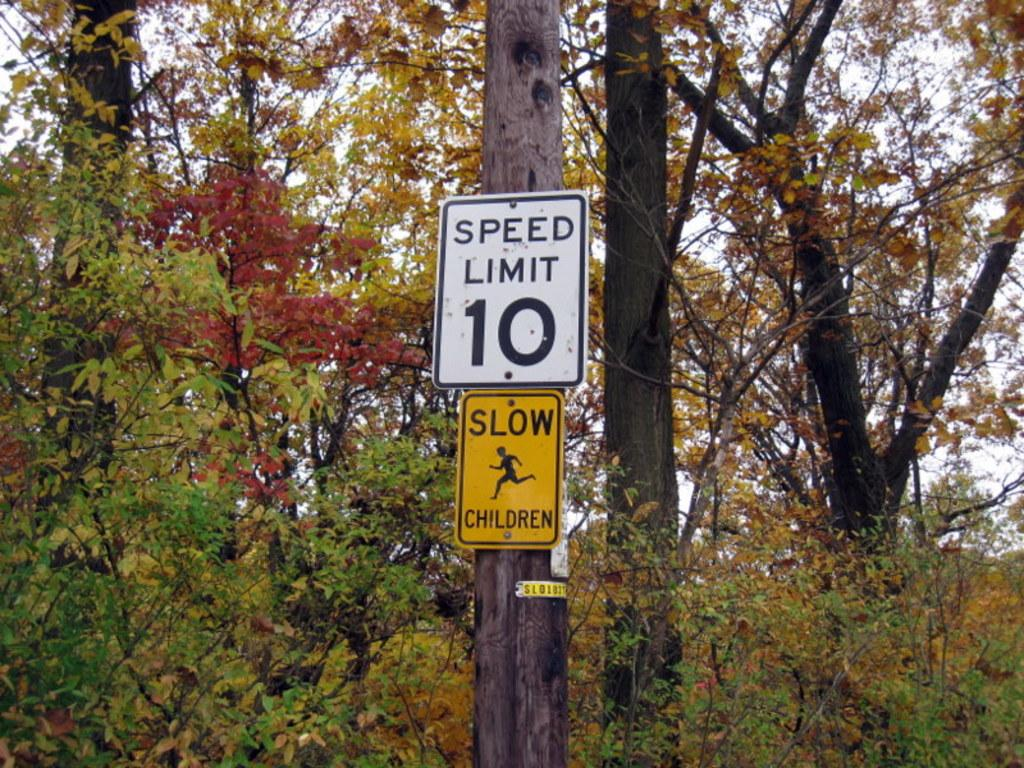What is attached to the tree trunk in the image? There are sign boards on a tree trunk in the image. What can be seen in the background of the image? There are trees in the background of the image. How does the ornament on the tree trunk in the image turn to face the camera? There is no ornament present on the tree trunk in the image; only sign boards are attached to it. 